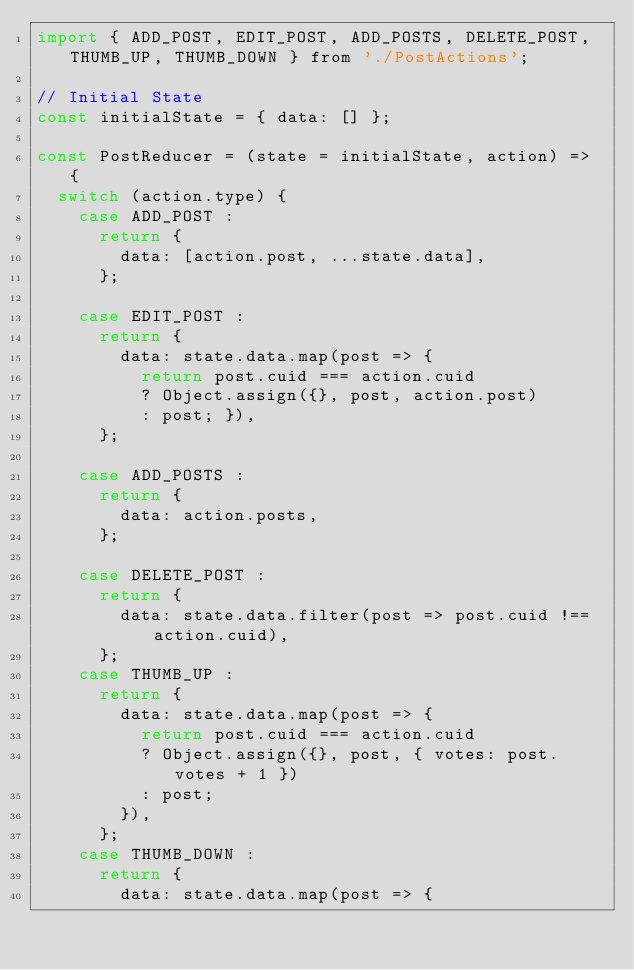<code> <loc_0><loc_0><loc_500><loc_500><_JavaScript_>import { ADD_POST, EDIT_POST, ADD_POSTS, DELETE_POST, THUMB_UP, THUMB_DOWN } from './PostActions';

// Initial State
const initialState = { data: [] };

const PostReducer = (state = initialState, action) => {
  switch (action.type) {
    case ADD_POST :
      return {
        data: [action.post, ...state.data],
      };

    case EDIT_POST :
      return {
        data: state.data.map(post => {
          return post.cuid === action.cuid
          ? Object.assign({}, post, action.post)
          : post; }),
      };

    case ADD_POSTS :
      return {
        data: action.posts,
      };

    case DELETE_POST :
      return {
        data: state.data.filter(post => post.cuid !== action.cuid),
      };
    case THUMB_UP :
      return {
        data: state.data.map(post => {
          return post.cuid === action.cuid
          ? Object.assign({}, post, { votes: post.votes + 1 })
          : post;
        }),
      };
    case THUMB_DOWN :
      return {
        data: state.data.map(post => {</code> 